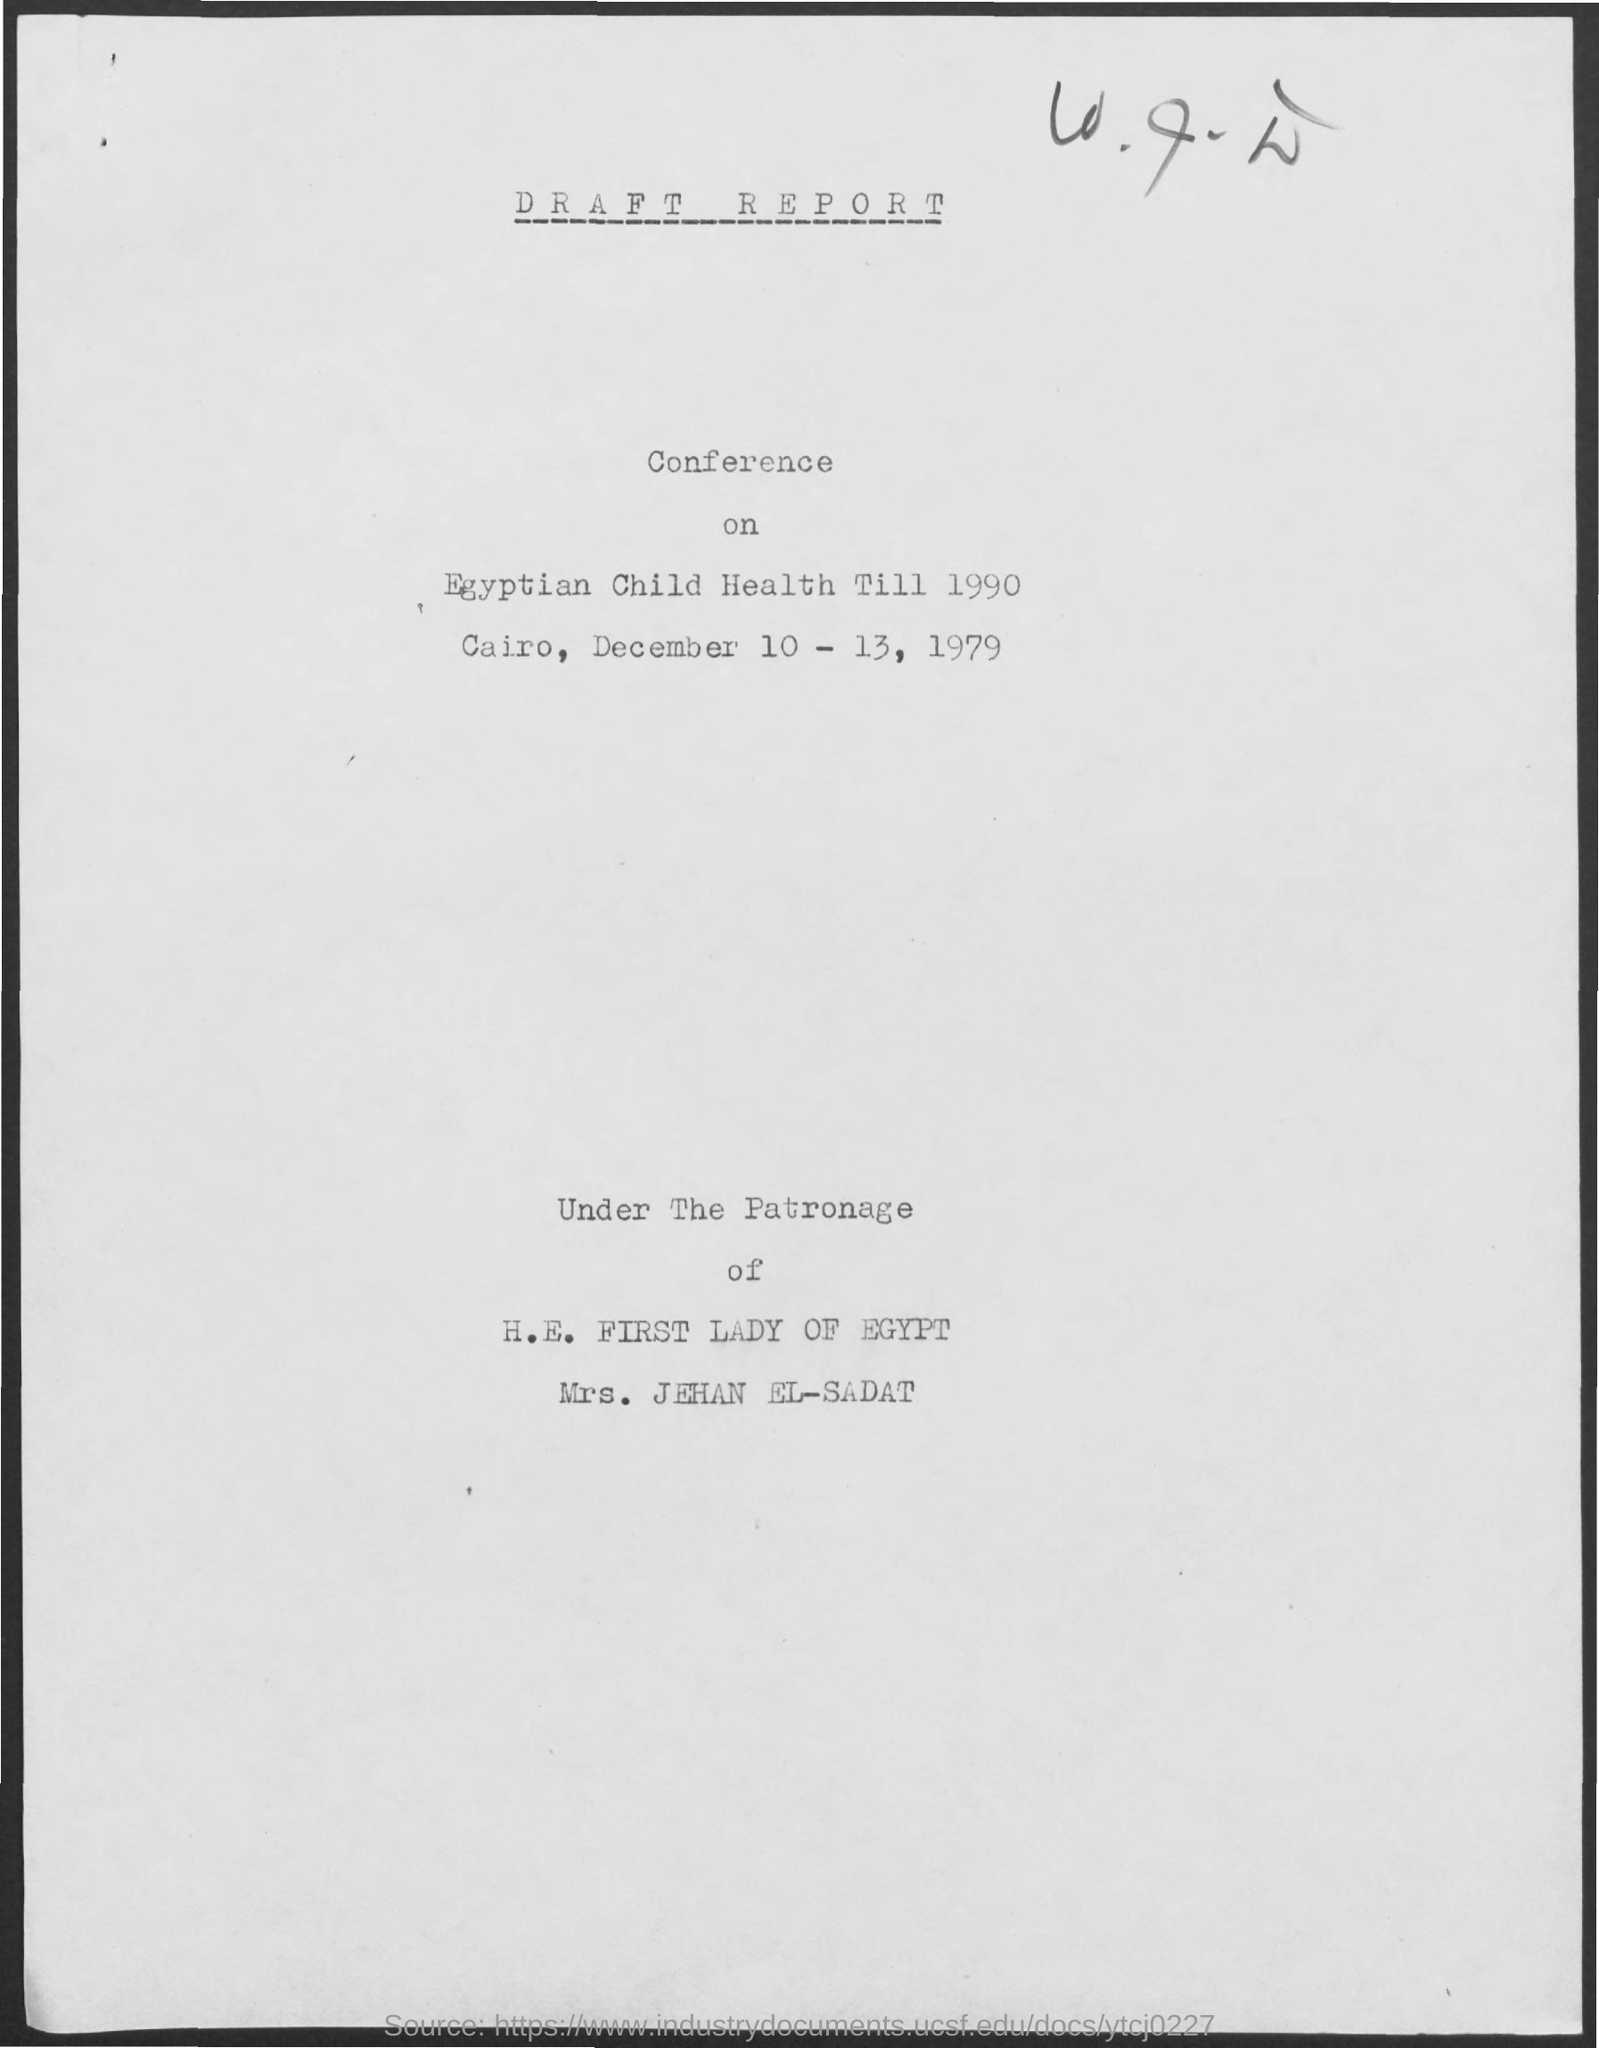When is the conference?
Ensure brevity in your answer.  December 10 - 13, 1979. Where is the conference?
Ensure brevity in your answer.  Cairo. 